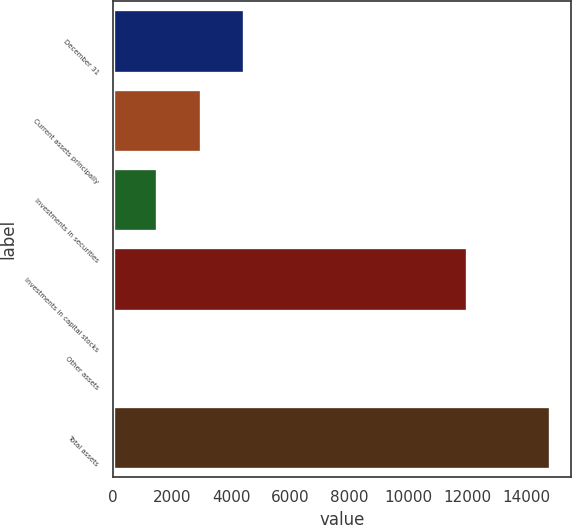Convert chart to OTSL. <chart><loc_0><loc_0><loc_500><loc_500><bar_chart><fcel>December 31<fcel>Current assets principally<fcel>Investments in securities<fcel>Investments in capital stocks<fcel>Other assets<fcel>Total assets<nl><fcel>4446.3<fcel>2971.2<fcel>1496.1<fcel>11973<fcel>21<fcel>14772<nl></chart> 